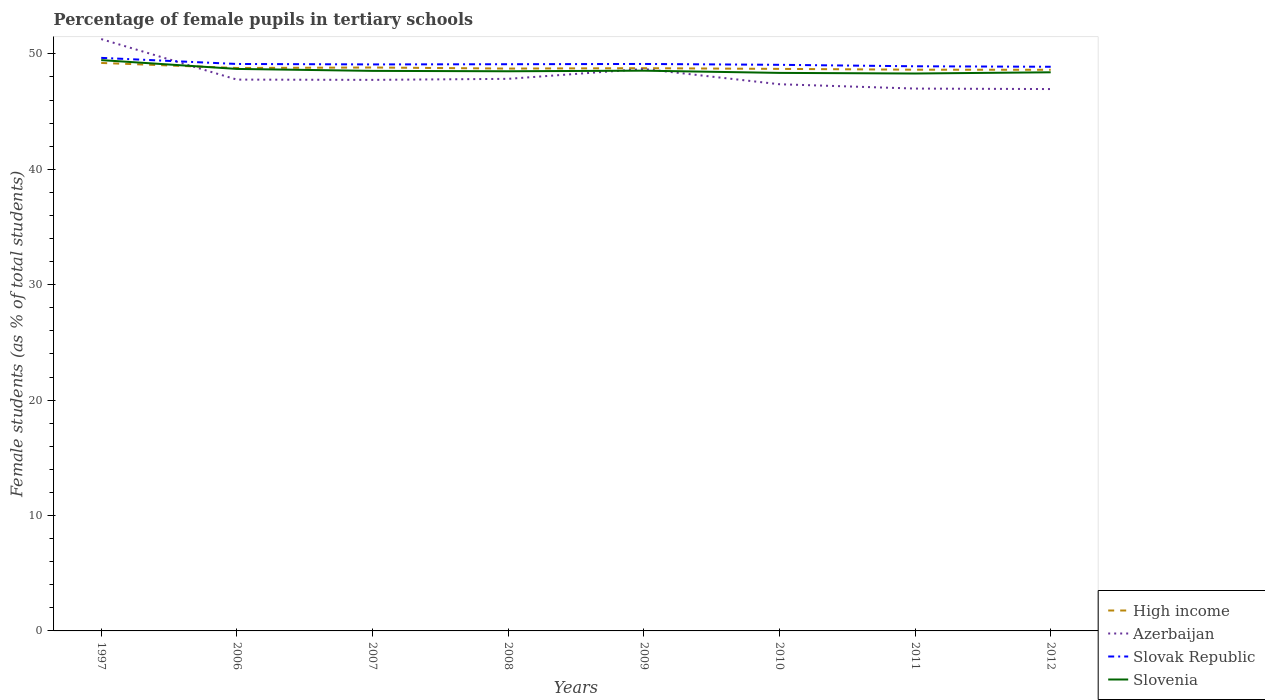Is the number of lines equal to the number of legend labels?
Your answer should be compact. Yes. Across all years, what is the maximum percentage of female pupils in tertiary schools in High income?
Offer a terse response. 48.62. What is the total percentage of female pupils in tertiary schools in Azerbaijan in the graph?
Offer a very short reply. 1.74. What is the difference between the highest and the second highest percentage of female pupils in tertiary schools in Slovak Republic?
Keep it short and to the point. 0.77. Is the percentage of female pupils in tertiary schools in Slovenia strictly greater than the percentage of female pupils in tertiary schools in Slovak Republic over the years?
Keep it short and to the point. Yes. How many lines are there?
Your answer should be very brief. 4. How many years are there in the graph?
Your answer should be very brief. 8. Are the values on the major ticks of Y-axis written in scientific E-notation?
Keep it short and to the point. No. Does the graph contain any zero values?
Your response must be concise. No. How many legend labels are there?
Offer a very short reply. 4. How are the legend labels stacked?
Make the answer very short. Vertical. What is the title of the graph?
Your answer should be compact. Percentage of female pupils in tertiary schools. What is the label or title of the X-axis?
Make the answer very short. Years. What is the label or title of the Y-axis?
Provide a short and direct response. Female students (as % of total students). What is the Female students (as % of total students) in High income in 1997?
Provide a short and direct response. 49.21. What is the Female students (as % of total students) in Azerbaijan in 1997?
Your response must be concise. 51.28. What is the Female students (as % of total students) of Slovak Republic in 1997?
Provide a short and direct response. 49.65. What is the Female students (as % of total students) in Slovenia in 1997?
Make the answer very short. 49.46. What is the Female students (as % of total students) of High income in 2006?
Keep it short and to the point. 48.78. What is the Female students (as % of total students) of Azerbaijan in 2006?
Give a very brief answer. 47.77. What is the Female students (as % of total students) of Slovak Republic in 2006?
Ensure brevity in your answer.  49.12. What is the Female students (as % of total students) of Slovenia in 2006?
Provide a short and direct response. 48.69. What is the Female students (as % of total students) of High income in 2007?
Ensure brevity in your answer.  48.82. What is the Female students (as % of total students) of Azerbaijan in 2007?
Offer a terse response. 47.74. What is the Female students (as % of total students) in Slovak Republic in 2007?
Provide a short and direct response. 49.08. What is the Female students (as % of total students) in Slovenia in 2007?
Your response must be concise. 48.52. What is the Female students (as % of total students) of High income in 2008?
Your answer should be very brief. 48.72. What is the Female students (as % of total students) in Azerbaijan in 2008?
Your answer should be compact. 47.83. What is the Female students (as % of total students) in Slovak Republic in 2008?
Keep it short and to the point. 49.1. What is the Female students (as % of total students) in Slovenia in 2008?
Make the answer very short. 48.49. What is the Female students (as % of total students) of High income in 2009?
Give a very brief answer. 48.76. What is the Female students (as % of total students) in Azerbaijan in 2009?
Your answer should be compact. 48.69. What is the Female students (as % of total students) of Slovak Republic in 2009?
Keep it short and to the point. 49.12. What is the Female students (as % of total students) of Slovenia in 2009?
Your response must be concise. 48.54. What is the Female students (as % of total students) in High income in 2010?
Your response must be concise. 48.7. What is the Female students (as % of total students) of Azerbaijan in 2010?
Your answer should be very brief. 47.37. What is the Female students (as % of total students) of Slovak Republic in 2010?
Provide a succinct answer. 49.05. What is the Female students (as % of total students) of Slovenia in 2010?
Your response must be concise. 48.35. What is the Female students (as % of total students) in High income in 2011?
Your response must be concise. 48.63. What is the Female students (as % of total students) in Azerbaijan in 2011?
Offer a terse response. 46.99. What is the Female students (as % of total students) of Slovak Republic in 2011?
Your answer should be compact. 48.92. What is the Female students (as % of total students) in Slovenia in 2011?
Provide a succinct answer. 48.3. What is the Female students (as % of total students) in High income in 2012?
Offer a terse response. 48.62. What is the Female students (as % of total students) in Azerbaijan in 2012?
Provide a short and direct response. 46.95. What is the Female students (as % of total students) of Slovak Republic in 2012?
Ensure brevity in your answer.  48.88. What is the Female students (as % of total students) of Slovenia in 2012?
Your answer should be compact. 48.4. Across all years, what is the maximum Female students (as % of total students) of High income?
Keep it short and to the point. 49.21. Across all years, what is the maximum Female students (as % of total students) of Azerbaijan?
Provide a short and direct response. 51.28. Across all years, what is the maximum Female students (as % of total students) in Slovak Republic?
Give a very brief answer. 49.65. Across all years, what is the maximum Female students (as % of total students) in Slovenia?
Ensure brevity in your answer.  49.46. Across all years, what is the minimum Female students (as % of total students) of High income?
Ensure brevity in your answer.  48.62. Across all years, what is the minimum Female students (as % of total students) of Azerbaijan?
Offer a very short reply. 46.95. Across all years, what is the minimum Female students (as % of total students) in Slovak Republic?
Keep it short and to the point. 48.88. Across all years, what is the minimum Female students (as % of total students) in Slovenia?
Keep it short and to the point. 48.3. What is the total Female students (as % of total students) in High income in the graph?
Your response must be concise. 390.23. What is the total Female students (as % of total students) in Azerbaijan in the graph?
Offer a terse response. 384.63. What is the total Female students (as % of total students) in Slovak Republic in the graph?
Your answer should be compact. 392.94. What is the total Female students (as % of total students) in Slovenia in the graph?
Ensure brevity in your answer.  388.76. What is the difference between the Female students (as % of total students) of High income in 1997 and that in 2006?
Offer a very short reply. 0.44. What is the difference between the Female students (as % of total students) of Azerbaijan in 1997 and that in 2006?
Your answer should be compact. 3.51. What is the difference between the Female students (as % of total students) of Slovak Republic in 1997 and that in 2006?
Your response must be concise. 0.53. What is the difference between the Female students (as % of total students) of Slovenia in 1997 and that in 2006?
Give a very brief answer. 0.76. What is the difference between the Female students (as % of total students) of High income in 1997 and that in 2007?
Your response must be concise. 0.4. What is the difference between the Female students (as % of total students) in Azerbaijan in 1997 and that in 2007?
Make the answer very short. 3.54. What is the difference between the Female students (as % of total students) in Slovak Republic in 1997 and that in 2007?
Keep it short and to the point. 0.57. What is the difference between the Female students (as % of total students) of Slovenia in 1997 and that in 2007?
Give a very brief answer. 0.93. What is the difference between the Female students (as % of total students) in High income in 1997 and that in 2008?
Your response must be concise. 0.49. What is the difference between the Female students (as % of total students) of Azerbaijan in 1997 and that in 2008?
Your answer should be compact. 3.45. What is the difference between the Female students (as % of total students) in Slovak Republic in 1997 and that in 2008?
Make the answer very short. 0.55. What is the difference between the Female students (as % of total students) of Slovenia in 1997 and that in 2008?
Your answer should be very brief. 0.97. What is the difference between the Female students (as % of total students) in High income in 1997 and that in 2009?
Make the answer very short. 0.45. What is the difference between the Female students (as % of total students) of Azerbaijan in 1997 and that in 2009?
Your answer should be compact. 2.59. What is the difference between the Female students (as % of total students) of Slovak Republic in 1997 and that in 2009?
Your answer should be very brief. 0.53. What is the difference between the Female students (as % of total students) in Slovenia in 1997 and that in 2009?
Keep it short and to the point. 0.92. What is the difference between the Female students (as % of total students) in High income in 1997 and that in 2010?
Keep it short and to the point. 0.51. What is the difference between the Female students (as % of total students) of Azerbaijan in 1997 and that in 2010?
Your response must be concise. 3.91. What is the difference between the Female students (as % of total students) in Slovak Republic in 1997 and that in 2010?
Keep it short and to the point. 0.6. What is the difference between the Female students (as % of total students) in Slovenia in 1997 and that in 2010?
Your response must be concise. 1.11. What is the difference between the Female students (as % of total students) of High income in 1997 and that in 2011?
Make the answer very short. 0.59. What is the difference between the Female students (as % of total students) of Azerbaijan in 1997 and that in 2011?
Give a very brief answer. 4.29. What is the difference between the Female students (as % of total students) of Slovak Republic in 1997 and that in 2011?
Provide a succinct answer. 0.73. What is the difference between the Female students (as % of total students) of Slovenia in 1997 and that in 2011?
Provide a short and direct response. 1.16. What is the difference between the Female students (as % of total students) of High income in 1997 and that in 2012?
Offer a very short reply. 0.59. What is the difference between the Female students (as % of total students) in Azerbaijan in 1997 and that in 2012?
Your answer should be very brief. 4.33. What is the difference between the Female students (as % of total students) of Slovak Republic in 1997 and that in 2012?
Ensure brevity in your answer.  0.77. What is the difference between the Female students (as % of total students) of Slovenia in 1997 and that in 2012?
Your answer should be very brief. 1.06. What is the difference between the Female students (as % of total students) in High income in 2006 and that in 2007?
Provide a succinct answer. -0.04. What is the difference between the Female students (as % of total students) in Azerbaijan in 2006 and that in 2007?
Make the answer very short. 0.02. What is the difference between the Female students (as % of total students) in Slovak Republic in 2006 and that in 2007?
Ensure brevity in your answer.  0.04. What is the difference between the Female students (as % of total students) in Slovenia in 2006 and that in 2007?
Give a very brief answer. 0.17. What is the difference between the Female students (as % of total students) in High income in 2006 and that in 2008?
Keep it short and to the point. 0.05. What is the difference between the Female students (as % of total students) of Azerbaijan in 2006 and that in 2008?
Provide a succinct answer. -0.07. What is the difference between the Female students (as % of total students) of Slovak Republic in 2006 and that in 2008?
Make the answer very short. 0.02. What is the difference between the Female students (as % of total students) of Slovenia in 2006 and that in 2008?
Your answer should be very brief. 0.2. What is the difference between the Female students (as % of total students) in High income in 2006 and that in 2009?
Keep it short and to the point. 0.02. What is the difference between the Female students (as % of total students) of Azerbaijan in 2006 and that in 2009?
Provide a succinct answer. -0.92. What is the difference between the Female students (as % of total students) in Slovak Republic in 2006 and that in 2009?
Provide a succinct answer. -0. What is the difference between the Female students (as % of total students) in Slovenia in 2006 and that in 2009?
Your answer should be compact. 0.15. What is the difference between the Female students (as % of total students) in High income in 2006 and that in 2010?
Make the answer very short. 0.08. What is the difference between the Female students (as % of total students) in Azerbaijan in 2006 and that in 2010?
Provide a succinct answer. 0.4. What is the difference between the Female students (as % of total students) in Slovak Republic in 2006 and that in 2010?
Make the answer very short. 0.07. What is the difference between the Female students (as % of total students) of Slovenia in 2006 and that in 2010?
Make the answer very short. 0.34. What is the difference between the Female students (as % of total students) in High income in 2006 and that in 2011?
Provide a succinct answer. 0.15. What is the difference between the Female students (as % of total students) in Azerbaijan in 2006 and that in 2011?
Your answer should be very brief. 0.78. What is the difference between the Female students (as % of total students) in Slovak Republic in 2006 and that in 2011?
Provide a short and direct response. 0.2. What is the difference between the Female students (as % of total students) of Slovenia in 2006 and that in 2011?
Provide a short and direct response. 0.4. What is the difference between the Female students (as % of total students) in High income in 2006 and that in 2012?
Give a very brief answer. 0.16. What is the difference between the Female students (as % of total students) in Azerbaijan in 2006 and that in 2012?
Offer a terse response. 0.82. What is the difference between the Female students (as % of total students) in Slovak Republic in 2006 and that in 2012?
Your answer should be very brief. 0.24. What is the difference between the Female students (as % of total students) in Slovenia in 2006 and that in 2012?
Provide a succinct answer. 0.29. What is the difference between the Female students (as % of total students) of High income in 2007 and that in 2008?
Make the answer very short. 0.09. What is the difference between the Female students (as % of total students) of Azerbaijan in 2007 and that in 2008?
Ensure brevity in your answer.  -0.09. What is the difference between the Female students (as % of total students) of Slovak Republic in 2007 and that in 2008?
Offer a terse response. -0.02. What is the difference between the Female students (as % of total students) of High income in 2007 and that in 2009?
Make the answer very short. 0.06. What is the difference between the Female students (as % of total students) in Azerbaijan in 2007 and that in 2009?
Provide a succinct answer. -0.94. What is the difference between the Female students (as % of total students) of Slovak Republic in 2007 and that in 2009?
Give a very brief answer. -0.04. What is the difference between the Female students (as % of total students) of Slovenia in 2007 and that in 2009?
Your answer should be very brief. -0.02. What is the difference between the Female students (as % of total students) of High income in 2007 and that in 2010?
Provide a short and direct response. 0.12. What is the difference between the Female students (as % of total students) of Azerbaijan in 2007 and that in 2010?
Make the answer very short. 0.38. What is the difference between the Female students (as % of total students) in Slovak Republic in 2007 and that in 2010?
Your answer should be compact. 0.03. What is the difference between the Female students (as % of total students) of Slovenia in 2007 and that in 2010?
Offer a very short reply. 0.17. What is the difference between the Female students (as % of total students) in High income in 2007 and that in 2011?
Make the answer very short. 0.19. What is the difference between the Female students (as % of total students) in Azerbaijan in 2007 and that in 2011?
Your response must be concise. 0.75. What is the difference between the Female students (as % of total students) of Slovak Republic in 2007 and that in 2011?
Keep it short and to the point. 0.16. What is the difference between the Female students (as % of total students) of Slovenia in 2007 and that in 2011?
Your response must be concise. 0.23. What is the difference between the Female students (as % of total students) in High income in 2007 and that in 2012?
Ensure brevity in your answer.  0.2. What is the difference between the Female students (as % of total students) of Azerbaijan in 2007 and that in 2012?
Offer a terse response. 0.8. What is the difference between the Female students (as % of total students) of Slovak Republic in 2007 and that in 2012?
Provide a succinct answer. 0.2. What is the difference between the Female students (as % of total students) of Slovenia in 2007 and that in 2012?
Your answer should be compact. 0.12. What is the difference between the Female students (as % of total students) in High income in 2008 and that in 2009?
Your answer should be very brief. -0.03. What is the difference between the Female students (as % of total students) of Azerbaijan in 2008 and that in 2009?
Make the answer very short. -0.86. What is the difference between the Female students (as % of total students) of Slovak Republic in 2008 and that in 2009?
Keep it short and to the point. -0.02. What is the difference between the Female students (as % of total students) in Slovenia in 2008 and that in 2009?
Offer a very short reply. -0.05. What is the difference between the Female students (as % of total students) in High income in 2008 and that in 2010?
Keep it short and to the point. 0.03. What is the difference between the Female students (as % of total students) in Azerbaijan in 2008 and that in 2010?
Offer a very short reply. 0.47. What is the difference between the Female students (as % of total students) of Slovak Republic in 2008 and that in 2010?
Offer a very short reply. 0.05. What is the difference between the Female students (as % of total students) in Slovenia in 2008 and that in 2010?
Provide a short and direct response. 0.14. What is the difference between the Female students (as % of total students) of High income in 2008 and that in 2011?
Make the answer very short. 0.1. What is the difference between the Female students (as % of total students) of Azerbaijan in 2008 and that in 2011?
Your response must be concise. 0.84. What is the difference between the Female students (as % of total students) of Slovak Republic in 2008 and that in 2011?
Offer a very short reply. 0.18. What is the difference between the Female students (as % of total students) of Slovenia in 2008 and that in 2011?
Your answer should be very brief. 0.19. What is the difference between the Female students (as % of total students) of High income in 2008 and that in 2012?
Your response must be concise. 0.11. What is the difference between the Female students (as % of total students) in Azerbaijan in 2008 and that in 2012?
Your response must be concise. 0.88. What is the difference between the Female students (as % of total students) in Slovak Republic in 2008 and that in 2012?
Your answer should be very brief. 0.22. What is the difference between the Female students (as % of total students) of Slovenia in 2008 and that in 2012?
Make the answer very short. 0.09. What is the difference between the Female students (as % of total students) of High income in 2009 and that in 2010?
Offer a very short reply. 0.06. What is the difference between the Female students (as % of total students) of Azerbaijan in 2009 and that in 2010?
Provide a succinct answer. 1.32. What is the difference between the Female students (as % of total students) in Slovak Republic in 2009 and that in 2010?
Ensure brevity in your answer.  0.07. What is the difference between the Female students (as % of total students) in Slovenia in 2009 and that in 2010?
Offer a very short reply. 0.19. What is the difference between the Female students (as % of total students) of High income in 2009 and that in 2011?
Your answer should be compact. 0.13. What is the difference between the Female students (as % of total students) of Azerbaijan in 2009 and that in 2011?
Offer a very short reply. 1.7. What is the difference between the Female students (as % of total students) of Slovak Republic in 2009 and that in 2011?
Provide a succinct answer. 0.2. What is the difference between the Female students (as % of total students) of Slovenia in 2009 and that in 2011?
Offer a terse response. 0.24. What is the difference between the Female students (as % of total students) of High income in 2009 and that in 2012?
Make the answer very short. 0.14. What is the difference between the Female students (as % of total students) in Azerbaijan in 2009 and that in 2012?
Offer a very short reply. 1.74. What is the difference between the Female students (as % of total students) in Slovak Republic in 2009 and that in 2012?
Your response must be concise. 0.24. What is the difference between the Female students (as % of total students) of Slovenia in 2009 and that in 2012?
Offer a terse response. 0.14. What is the difference between the Female students (as % of total students) in High income in 2010 and that in 2011?
Keep it short and to the point. 0.07. What is the difference between the Female students (as % of total students) in Azerbaijan in 2010 and that in 2011?
Your answer should be compact. 0.38. What is the difference between the Female students (as % of total students) in Slovak Republic in 2010 and that in 2011?
Keep it short and to the point. 0.13. What is the difference between the Female students (as % of total students) in Slovenia in 2010 and that in 2011?
Make the answer very short. 0.05. What is the difference between the Female students (as % of total students) of High income in 2010 and that in 2012?
Your answer should be compact. 0.08. What is the difference between the Female students (as % of total students) of Azerbaijan in 2010 and that in 2012?
Provide a short and direct response. 0.42. What is the difference between the Female students (as % of total students) of Slovak Republic in 2010 and that in 2012?
Provide a short and direct response. 0.17. What is the difference between the Female students (as % of total students) in Slovenia in 2010 and that in 2012?
Your answer should be compact. -0.05. What is the difference between the Female students (as % of total students) in High income in 2011 and that in 2012?
Your answer should be very brief. 0.01. What is the difference between the Female students (as % of total students) in Azerbaijan in 2011 and that in 2012?
Ensure brevity in your answer.  0.04. What is the difference between the Female students (as % of total students) of Slovak Republic in 2011 and that in 2012?
Give a very brief answer. 0.04. What is the difference between the Female students (as % of total students) of Slovenia in 2011 and that in 2012?
Provide a succinct answer. -0.1. What is the difference between the Female students (as % of total students) in High income in 1997 and the Female students (as % of total students) in Azerbaijan in 2006?
Ensure brevity in your answer.  1.44. What is the difference between the Female students (as % of total students) in High income in 1997 and the Female students (as % of total students) in Slovak Republic in 2006?
Offer a very short reply. 0.09. What is the difference between the Female students (as % of total students) in High income in 1997 and the Female students (as % of total students) in Slovenia in 2006?
Offer a terse response. 0.52. What is the difference between the Female students (as % of total students) of Azerbaijan in 1997 and the Female students (as % of total students) of Slovak Republic in 2006?
Make the answer very short. 2.16. What is the difference between the Female students (as % of total students) of Azerbaijan in 1997 and the Female students (as % of total students) of Slovenia in 2006?
Your response must be concise. 2.59. What is the difference between the Female students (as % of total students) of Slovak Republic in 1997 and the Female students (as % of total students) of Slovenia in 2006?
Give a very brief answer. 0.96. What is the difference between the Female students (as % of total students) of High income in 1997 and the Female students (as % of total students) of Azerbaijan in 2007?
Keep it short and to the point. 1.47. What is the difference between the Female students (as % of total students) of High income in 1997 and the Female students (as % of total students) of Slovak Republic in 2007?
Your response must be concise. 0.13. What is the difference between the Female students (as % of total students) of High income in 1997 and the Female students (as % of total students) of Slovenia in 2007?
Keep it short and to the point. 0.69. What is the difference between the Female students (as % of total students) in Azerbaijan in 1997 and the Female students (as % of total students) in Slovak Republic in 2007?
Offer a terse response. 2.2. What is the difference between the Female students (as % of total students) of Azerbaijan in 1997 and the Female students (as % of total students) of Slovenia in 2007?
Make the answer very short. 2.76. What is the difference between the Female students (as % of total students) of Slovak Republic in 1997 and the Female students (as % of total students) of Slovenia in 2007?
Provide a succinct answer. 1.13. What is the difference between the Female students (as % of total students) in High income in 1997 and the Female students (as % of total students) in Azerbaijan in 2008?
Keep it short and to the point. 1.38. What is the difference between the Female students (as % of total students) of High income in 1997 and the Female students (as % of total students) of Slovak Republic in 2008?
Keep it short and to the point. 0.11. What is the difference between the Female students (as % of total students) in High income in 1997 and the Female students (as % of total students) in Slovenia in 2008?
Your answer should be compact. 0.72. What is the difference between the Female students (as % of total students) in Azerbaijan in 1997 and the Female students (as % of total students) in Slovak Republic in 2008?
Offer a terse response. 2.18. What is the difference between the Female students (as % of total students) in Azerbaijan in 1997 and the Female students (as % of total students) in Slovenia in 2008?
Keep it short and to the point. 2.79. What is the difference between the Female students (as % of total students) of Slovak Republic in 1997 and the Female students (as % of total students) of Slovenia in 2008?
Provide a succinct answer. 1.16. What is the difference between the Female students (as % of total students) of High income in 1997 and the Female students (as % of total students) of Azerbaijan in 2009?
Your answer should be compact. 0.52. What is the difference between the Female students (as % of total students) of High income in 1997 and the Female students (as % of total students) of Slovak Republic in 2009?
Your response must be concise. 0.09. What is the difference between the Female students (as % of total students) of High income in 1997 and the Female students (as % of total students) of Slovenia in 2009?
Your response must be concise. 0.67. What is the difference between the Female students (as % of total students) of Azerbaijan in 1997 and the Female students (as % of total students) of Slovak Republic in 2009?
Provide a succinct answer. 2.16. What is the difference between the Female students (as % of total students) of Azerbaijan in 1997 and the Female students (as % of total students) of Slovenia in 2009?
Make the answer very short. 2.74. What is the difference between the Female students (as % of total students) of Slovak Republic in 1997 and the Female students (as % of total students) of Slovenia in 2009?
Keep it short and to the point. 1.11. What is the difference between the Female students (as % of total students) in High income in 1997 and the Female students (as % of total students) in Azerbaijan in 2010?
Provide a succinct answer. 1.84. What is the difference between the Female students (as % of total students) of High income in 1997 and the Female students (as % of total students) of Slovak Republic in 2010?
Ensure brevity in your answer.  0.16. What is the difference between the Female students (as % of total students) of High income in 1997 and the Female students (as % of total students) of Slovenia in 2010?
Give a very brief answer. 0.86. What is the difference between the Female students (as % of total students) in Azerbaijan in 1997 and the Female students (as % of total students) in Slovak Republic in 2010?
Your response must be concise. 2.23. What is the difference between the Female students (as % of total students) in Azerbaijan in 1997 and the Female students (as % of total students) in Slovenia in 2010?
Your response must be concise. 2.93. What is the difference between the Female students (as % of total students) in Slovak Republic in 1997 and the Female students (as % of total students) in Slovenia in 2010?
Keep it short and to the point. 1.3. What is the difference between the Female students (as % of total students) in High income in 1997 and the Female students (as % of total students) in Azerbaijan in 2011?
Offer a terse response. 2.22. What is the difference between the Female students (as % of total students) in High income in 1997 and the Female students (as % of total students) in Slovak Republic in 2011?
Provide a succinct answer. 0.29. What is the difference between the Female students (as % of total students) of High income in 1997 and the Female students (as % of total students) of Slovenia in 2011?
Provide a short and direct response. 0.91. What is the difference between the Female students (as % of total students) of Azerbaijan in 1997 and the Female students (as % of total students) of Slovak Republic in 2011?
Your answer should be compact. 2.36. What is the difference between the Female students (as % of total students) of Azerbaijan in 1997 and the Female students (as % of total students) of Slovenia in 2011?
Ensure brevity in your answer.  2.98. What is the difference between the Female students (as % of total students) in Slovak Republic in 1997 and the Female students (as % of total students) in Slovenia in 2011?
Your answer should be compact. 1.35. What is the difference between the Female students (as % of total students) of High income in 1997 and the Female students (as % of total students) of Azerbaijan in 2012?
Ensure brevity in your answer.  2.26. What is the difference between the Female students (as % of total students) of High income in 1997 and the Female students (as % of total students) of Slovak Republic in 2012?
Make the answer very short. 0.33. What is the difference between the Female students (as % of total students) of High income in 1997 and the Female students (as % of total students) of Slovenia in 2012?
Keep it short and to the point. 0.81. What is the difference between the Female students (as % of total students) in Azerbaijan in 1997 and the Female students (as % of total students) in Slovak Republic in 2012?
Ensure brevity in your answer.  2.4. What is the difference between the Female students (as % of total students) in Azerbaijan in 1997 and the Female students (as % of total students) in Slovenia in 2012?
Ensure brevity in your answer.  2.88. What is the difference between the Female students (as % of total students) in Slovak Republic in 1997 and the Female students (as % of total students) in Slovenia in 2012?
Give a very brief answer. 1.25. What is the difference between the Female students (as % of total students) in High income in 2006 and the Female students (as % of total students) in Azerbaijan in 2007?
Offer a terse response. 1.03. What is the difference between the Female students (as % of total students) of High income in 2006 and the Female students (as % of total students) of Slovak Republic in 2007?
Offer a terse response. -0.31. What is the difference between the Female students (as % of total students) in High income in 2006 and the Female students (as % of total students) in Slovenia in 2007?
Offer a terse response. 0.25. What is the difference between the Female students (as % of total students) in Azerbaijan in 2006 and the Female students (as % of total students) in Slovak Republic in 2007?
Offer a terse response. -1.32. What is the difference between the Female students (as % of total students) of Azerbaijan in 2006 and the Female students (as % of total students) of Slovenia in 2007?
Provide a succinct answer. -0.76. What is the difference between the Female students (as % of total students) of Slovak Republic in 2006 and the Female students (as % of total students) of Slovenia in 2007?
Make the answer very short. 0.6. What is the difference between the Female students (as % of total students) of High income in 2006 and the Female students (as % of total students) of Azerbaijan in 2008?
Keep it short and to the point. 0.94. What is the difference between the Female students (as % of total students) of High income in 2006 and the Female students (as % of total students) of Slovak Republic in 2008?
Give a very brief answer. -0.33. What is the difference between the Female students (as % of total students) in High income in 2006 and the Female students (as % of total students) in Slovenia in 2008?
Make the answer very short. 0.28. What is the difference between the Female students (as % of total students) in Azerbaijan in 2006 and the Female students (as % of total students) in Slovak Republic in 2008?
Your response must be concise. -1.33. What is the difference between the Female students (as % of total students) in Azerbaijan in 2006 and the Female students (as % of total students) in Slovenia in 2008?
Offer a very short reply. -0.72. What is the difference between the Female students (as % of total students) of Slovak Republic in 2006 and the Female students (as % of total students) of Slovenia in 2008?
Your answer should be compact. 0.63. What is the difference between the Female students (as % of total students) of High income in 2006 and the Female students (as % of total students) of Azerbaijan in 2009?
Ensure brevity in your answer.  0.09. What is the difference between the Female students (as % of total students) of High income in 2006 and the Female students (as % of total students) of Slovak Republic in 2009?
Provide a short and direct response. -0.35. What is the difference between the Female students (as % of total students) of High income in 2006 and the Female students (as % of total students) of Slovenia in 2009?
Offer a very short reply. 0.23. What is the difference between the Female students (as % of total students) of Azerbaijan in 2006 and the Female students (as % of total students) of Slovak Republic in 2009?
Give a very brief answer. -1.35. What is the difference between the Female students (as % of total students) of Azerbaijan in 2006 and the Female students (as % of total students) of Slovenia in 2009?
Ensure brevity in your answer.  -0.77. What is the difference between the Female students (as % of total students) in Slovak Republic in 2006 and the Female students (as % of total students) in Slovenia in 2009?
Your answer should be compact. 0.58. What is the difference between the Female students (as % of total students) in High income in 2006 and the Female students (as % of total students) in Azerbaijan in 2010?
Provide a short and direct response. 1.41. What is the difference between the Female students (as % of total students) in High income in 2006 and the Female students (as % of total students) in Slovak Republic in 2010?
Provide a succinct answer. -0.27. What is the difference between the Female students (as % of total students) in High income in 2006 and the Female students (as % of total students) in Slovenia in 2010?
Ensure brevity in your answer.  0.43. What is the difference between the Female students (as % of total students) of Azerbaijan in 2006 and the Female students (as % of total students) of Slovak Republic in 2010?
Provide a succinct answer. -1.28. What is the difference between the Female students (as % of total students) of Azerbaijan in 2006 and the Female students (as % of total students) of Slovenia in 2010?
Provide a short and direct response. -0.58. What is the difference between the Female students (as % of total students) in Slovak Republic in 2006 and the Female students (as % of total students) in Slovenia in 2010?
Offer a very short reply. 0.77. What is the difference between the Female students (as % of total students) in High income in 2006 and the Female students (as % of total students) in Azerbaijan in 2011?
Provide a short and direct response. 1.78. What is the difference between the Female students (as % of total students) in High income in 2006 and the Female students (as % of total students) in Slovak Republic in 2011?
Keep it short and to the point. -0.15. What is the difference between the Female students (as % of total students) of High income in 2006 and the Female students (as % of total students) of Slovenia in 2011?
Make the answer very short. 0.48. What is the difference between the Female students (as % of total students) of Azerbaijan in 2006 and the Female students (as % of total students) of Slovak Republic in 2011?
Provide a short and direct response. -1.15. What is the difference between the Female students (as % of total students) of Azerbaijan in 2006 and the Female students (as % of total students) of Slovenia in 2011?
Offer a terse response. -0.53. What is the difference between the Female students (as % of total students) of Slovak Republic in 2006 and the Female students (as % of total students) of Slovenia in 2011?
Provide a short and direct response. 0.83. What is the difference between the Female students (as % of total students) in High income in 2006 and the Female students (as % of total students) in Azerbaijan in 2012?
Your answer should be very brief. 1.83. What is the difference between the Female students (as % of total students) in High income in 2006 and the Female students (as % of total students) in Slovak Republic in 2012?
Offer a terse response. -0.11. What is the difference between the Female students (as % of total students) of High income in 2006 and the Female students (as % of total students) of Slovenia in 2012?
Make the answer very short. 0.37. What is the difference between the Female students (as % of total students) in Azerbaijan in 2006 and the Female students (as % of total students) in Slovak Republic in 2012?
Keep it short and to the point. -1.11. What is the difference between the Female students (as % of total students) of Azerbaijan in 2006 and the Female students (as % of total students) of Slovenia in 2012?
Ensure brevity in your answer.  -0.63. What is the difference between the Female students (as % of total students) in Slovak Republic in 2006 and the Female students (as % of total students) in Slovenia in 2012?
Your answer should be compact. 0.72. What is the difference between the Female students (as % of total students) in High income in 2007 and the Female students (as % of total students) in Azerbaijan in 2008?
Offer a terse response. 0.98. What is the difference between the Female students (as % of total students) of High income in 2007 and the Female students (as % of total students) of Slovak Republic in 2008?
Give a very brief answer. -0.28. What is the difference between the Female students (as % of total students) in High income in 2007 and the Female students (as % of total students) in Slovenia in 2008?
Give a very brief answer. 0.32. What is the difference between the Female students (as % of total students) of Azerbaijan in 2007 and the Female students (as % of total students) of Slovak Republic in 2008?
Give a very brief answer. -1.36. What is the difference between the Female students (as % of total students) of Azerbaijan in 2007 and the Female students (as % of total students) of Slovenia in 2008?
Give a very brief answer. -0.75. What is the difference between the Female students (as % of total students) of Slovak Republic in 2007 and the Female students (as % of total students) of Slovenia in 2008?
Offer a very short reply. 0.59. What is the difference between the Female students (as % of total students) of High income in 2007 and the Female students (as % of total students) of Azerbaijan in 2009?
Provide a succinct answer. 0.13. What is the difference between the Female students (as % of total students) of High income in 2007 and the Female students (as % of total students) of Slovak Republic in 2009?
Offer a very short reply. -0.31. What is the difference between the Female students (as % of total students) of High income in 2007 and the Female students (as % of total students) of Slovenia in 2009?
Your answer should be compact. 0.27. What is the difference between the Female students (as % of total students) of Azerbaijan in 2007 and the Female students (as % of total students) of Slovak Republic in 2009?
Your response must be concise. -1.38. What is the difference between the Female students (as % of total students) of Azerbaijan in 2007 and the Female students (as % of total students) of Slovenia in 2009?
Ensure brevity in your answer.  -0.8. What is the difference between the Female students (as % of total students) of Slovak Republic in 2007 and the Female students (as % of total students) of Slovenia in 2009?
Make the answer very short. 0.54. What is the difference between the Female students (as % of total students) of High income in 2007 and the Female students (as % of total students) of Azerbaijan in 2010?
Keep it short and to the point. 1.45. What is the difference between the Female students (as % of total students) of High income in 2007 and the Female students (as % of total students) of Slovak Republic in 2010?
Your answer should be very brief. -0.23. What is the difference between the Female students (as % of total students) in High income in 2007 and the Female students (as % of total students) in Slovenia in 2010?
Give a very brief answer. 0.47. What is the difference between the Female students (as % of total students) in Azerbaijan in 2007 and the Female students (as % of total students) in Slovak Republic in 2010?
Make the answer very short. -1.3. What is the difference between the Female students (as % of total students) of Azerbaijan in 2007 and the Female students (as % of total students) of Slovenia in 2010?
Your answer should be very brief. -0.6. What is the difference between the Female students (as % of total students) of Slovak Republic in 2007 and the Female students (as % of total students) of Slovenia in 2010?
Provide a succinct answer. 0.73. What is the difference between the Female students (as % of total students) of High income in 2007 and the Female students (as % of total students) of Azerbaijan in 2011?
Your answer should be compact. 1.83. What is the difference between the Female students (as % of total students) of High income in 2007 and the Female students (as % of total students) of Slovak Republic in 2011?
Your answer should be compact. -0.11. What is the difference between the Female students (as % of total students) in High income in 2007 and the Female students (as % of total students) in Slovenia in 2011?
Your answer should be very brief. 0.52. What is the difference between the Female students (as % of total students) in Azerbaijan in 2007 and the Female students (as % of total students) in Slovak Republic in 2011?
Offer a very short reply. -1.18. What is the difference between the Female students (as % of total students) of Azerbaijan in 2007 and the Female students (as % of total students) of Slovenia in 2011?
Make the answer very short. -0.55. What is the difference between the Female students (as % of total students) in Slovak Republic in 2007 and the Female students (as % of total students) in Slovenia in 2011?
Ensure brevity in your answer.  0.79. What is the difference between the Female students (as % of total students) of High income in 2007 and the Female students (as % of total students) of Azerbaijan in 2012?
Ensure brevity in your answer.  1.87. What is the difference between the Female students (as % of total students) in High income in 2007 and the Female students (as % of total students) in Slovak Republic in 2012?
Your response must be concise. -0.06. What is the difference between the Female students (as % of total students) of High income in 2007 and the Female students (as % of total students) of Slovenia in 2012?
Offer a terse response. 0.41. What is the difference between the Female students (as % of total students) in Azerbaijan in 2007 and the Female students (as % of total students) in Slovak Republic in 2012?
Make the answer very short. -1.14. What is the difference between the Female students (as % of total students) in Azerbaijan in 2007 and the Female students (as % of total students) in Slovenia in 2012?
Keep it short and to the point. -0.66. What is the difference between the Female students (as % of total students) of Slovak Republic in 2007 and the Female students (as % of total students) of Slovenia in 2012?
Ensure brevity in your answer.  0.68. What is the difference between the Female students (as % of total students) of High income in 2008 and the Female students (as % of total students) of Azerbaijan in 2009?
Make the answer very short. 0.04. What is the difference between the Female students (as % of total students) in High income in 2008 and the Female students (as % of total students) in Slovak Republic in 2009?
Offer a terse response. -0.4. What is the difference between the Female students (as % of total students) of High income in 2008 and the Female students (as % of total students) of Slovenia in 2009?
Ensure brevity in your answer.  0.18. What is the difference between the Female students (as % of total students) of Azerbaijan in 2008 and the Female students (as % of total students) of Slovak Republic in 2009?
Give a very brief answer. -1.29. What is the difference between the Female students (as % of total students) in Azerbaijan in 2008 and the Female students (as % of total students) in Slovenia in 2009?
Offer a terse response. -0.71. What is the difference between the Female students (as % of total students) of Slovak Republic in 2008 and the Female students (as % of total students) of Slovenia in 2009?
Provide a short and direct response. 0.56. What is the difference between the Female students (as % of total students) in High income in 2008 and the Female students (as % of total students) in Azerbaijan in 2010?
Keep it short and to the point. 1.36. What is the difference between the Female students (as % of total students) of High income in 2008 and the Female students (as % of total students) of Slovak Republic in 2010?
Your response must be concise. -0.32. What is the difference between the Female students (as % of total students) of High income in 2008 and the Female students (as % of total students) of Slovenia in 2010?
Keep it short and to the point. 0.38. What is the difference between the Female students (as % of total students) in Azerbaijan in 2008 and the Female students (as % of total students) in Slovak Republic in 2010?
Provide a succinct answer. -1.22. What is the difference between the Female students (as % of total students) of Azerbaijan in 2008 and the Female students (as % of total students) of Slovenia in 2010?
Ensure brevity in your answer.  -0.52. What is the difference between the Female students (as % of total students) in Slovak Republic in 2008 and the Female students (as % of total students) in Slovenia in 2010?
Ensure brevity in your answer.  0.75. What is the difference between the Female students (as % of total students) in High income in 2008 and the Female students (as % of total students) in Azerbaijan in 2011?
Your answer should be very brief. 1.73. What is the difference between the Female students (as % of total students) in High income in 2008 and the Female students (as % of total students) in Slovak Republic in 2011?
Your response must be concise. -0.2. What is the difference between the Female students (as % of total students) of High income in 2008 and the Female students (as % of total students) of Slovenia in 2011?
Keep it short and to the point. 0.43. What is the difference between the Female students (as % of total students) in Azerbaijan in 2008 and the Female students (as % of total students) in Slovak Republic in 2011?
Keep it short and to the point. -1.09. What is the difference between the Female students (as % of total students) in Azerbaijan in 2008 and the Female students (as % of total students) in Slovenia in 2011?
Your response must be concise. -0.46. What is the difference between the Female students (as % of total students) of Slovak Republic in 2008 and the Female students (as % of total students) of Slovenia in 2011?
Provide a succinct answer. 0.8. What is the difference between the Female students (as % of total students) in High income in 2008 and the Female students (as % of total students) in Azerbaijan in 2012?
Make the answer very short. 1.78. What is the difference between the Female students (as % of total students) of High income in 2008 and the Female students (as % of total students) of Slovak Republic in 2012?
Provide a short and direct response. -0.16. What is the difference between the Female students (as % of total students) of High income in 2008 and the Female students (as % of total students) of Slovenia in 2012?
Ensure brevity in your answer.  0.32. What is the difference between the Female students (as % of total students) in Azerbaijan in 2008 and the Female students (as % of total students) in Slovak Republic in 2012?
Make the answer very short. -1.05. What is the difference between the Female students (as % of total students) of Azerbaijan in 2008 and the Female students (as % of total students) of Slovenia in 2012?
Provide a short and direct response. -0.57. What is the difference between the Female students (as % of total students) in Slovak Republic in 2008 and the Female students (as % of total students) in Slovenia in 2012?
Offer a very short reply. 0.7. What is the difference between the Female students (as % of total students) in High income in 2009 and the Female students (as % of total students) in Azerbaijan in 2010?
Your answer should be compact. 1.39. What is the difference between the Female students (as % of total students) in High income in 2009 and the Female students (as % of total students) in Slovak Republic in 2010?
Ensure brevity in your answer.  -0.29. What is the difference between the Female students (as % of total students) of High income in 2009 and the Female students (as % of total students) of Slovenia in 2010?
Your response must be concise. 0.41. What is the difference between the Female students (as % of total students) in Azerbaijan in 2009 and the Female students (as % of total students) in Slovak Republic in 2010?
Your response must be concise. -0.36. What is the difference between the Female students (as % of total students) in Azerbaijan in 2009 and the Female students (as % of total students) in Slovenia in 2010?
Provide a short and direct response. 0.34. What is the difference between the Female students (as % of total students) in Slovak Republic in 2009 and the Female students (as % of total students) in Slovenia in 2010?
Give a very brief answer. 0.77. What is the difference between the Female students (as % of total students) of High income in 2009 and the Female students (as % of total students) of Azerbaijan in 2011?
Your answer should be compact. 1.77. What is the difference between the Female students (as % of total students) in High income in 2009 and the Female students (as % of total students) in Slovak Republic in 2011?
Your answer should be compact. -0.17. What is the difference between the Female students (as % of total students) of High income in 2009 and the Female students (as % of total students) of Slovenia in 2011?
Your answer should be compact. 0.46. What is the difference between the Female students (as % of total students) in Azerbaijan in 2009 and the Female students (as % of total students) in Slovak Republic in 2011?
Provide a short and direct response. -0.23. What is the difference between the Female students (as % of total students) in Azerbaijan in 2009 and the Female students (as % of total students) in Slovenia in 2011?
Provide a succinct answer. 0.39. What is the difference between the Female students (as % of total students) in Slovak Republic in 2009 and the Female students (as % of total students) in Slovenia in 2011?
Offer a terse response. 0.83. What is the difference between the Female students (as % of total students) in High income in 2009 and the Female students (as % of total students) in Azerbaijan in 2012?
Ensure brevity in your answer.  1.81. What is the difference between the Female students (as % of total students) in High income in 2009 and the Female students (as % of total students) in Slovak Republic in 2012?
Keep it short and to the point. -0.12. What is the difference between the Female students (as % of total students) of High income in 2009 and the Female students (as % of total students) of Slovenia in 2012?
Ensure brevity in your answer.  0.36. What is the difference between the Female students (as % of total students) of Azerbaijan in 2009 and the Female students (as % of total students) of Slovak Republic in 2012?
Ensure brevity in your answer.  -0.19. What is the difference between the Female students (as % of total students) in Azerbaijan in 2009 and the Female students (as % of total students) in Slovenia in 2012?
Offer a terse response. 0.29. What is the difference between the Female students (as % of total students) in Slovak Republic in 2009 and the Female students (as % of total students) in Slovenia in 2012?
Provide a succinct answer. 0.72. What is the difference between the Female students (as % of total students) in High income in 2010 and the Female students (as % of total students) in Azerbaijan in 2011?
Make the answer very short. 1.71. What is the difference between the Female students (as % of total students) of High income in 2010 and the Female students (as % of total students) of Slovak Republic in 2011?
Your answer should be compact. -0.23. What is the difference between the Female students (as % of total students) of High income in 2010 and the Female students (as % of total students) of Slovenia in 2011?
Your answer should be compact. 0.4. What is the difference between the Female students (as % of total students) in Azerbaijan in 2010 and the Female students (as % of total students) in Slovak Republic in 2011?
Give a very brief answer. -1.56. What is the difference between the Female students (as % of total students) in Azerbaijan in 2010 and the Female students (as % of total students) in Slovenia in 2011?
Your answer should be very brief. -0.93. What is the difference between the Female students (as % of total students) in Slovak Republic in 2010 and the Female students (as % of total students) in Slovenia in 2011?
Your answer should be very brief. 0.75. What is the difference between the Female students (as % of total students) in High income in 2010 and the Female students (as % of total students) in Azerbaijan in 2012?
Provide a succinct answer. 1.75. What is the difference between the Female students (as % of total students) in High income in 2010 and the Female students (as % of total students) in Slovak Republic in 2012?
Your answer should be compact. -0.18. What is the difference between the Female students (as % of total students) in High income in 2010 and the Female students (as % of total students) in Slovenia in 2012?
Offer a terse response. 0.3. What is the difference between the Female students (as % of total students) in Azerbaijan in 2010 and the Female students (as % of total students) in Slovak Republic in 2012?
Keep it short and to the point. -1.51. What is the difference between the Female students (as % of total students) of Azerbaijan in 2010 and the Female students (as % of total students) of Slovenia in 2012?
Make the answer very short. -1.03. What is the difference between the Female students (as % of total students) of Slovak Republic in 2010 and the Female students (as % of total students) of Slovenia in 2012?
Offer a very short reply. 0.65. What is the difference between the Female students (as % of total students) in High income in 2011 and the Female students (as % of total students) in Azerbaijan in 2012?
Ensure brevity in your answer.  1.68. What is the difference between the Female students (as % of total students) in High income in 2011 and the Female students (as % of total students) in Slovak Republic in 2012?
Provide a short and direct response. -0.25. What is the difference between the Female students (as % of total students) of High income in 2011 and the Female students (as % of total students) of Slovenia in 2012?
Your response must be concise. 0.23. What is the difference between the Female students (as % of total students) in Azerbaijan in 2011 and the Female students (as % of total students) in Slovak Republic in 2012?
Ensure brevity in your answer.  -1.89. What is the difference between the Female students (as % of total students) of Azerbaijan in 2011 and the Female students (as % of total students) of Slovenia in 2012?
Offer a very short reply. -1.41. What is the difference between the Female students (as % of total students) of Slovak Republic in 2011 and the Female students (as % of total students) of Slovenia in 2012?
Offer a terse response. 0.52. What is the average Female students (as % of total students) of High income per year?
Make the answer very short. 48.78. What is the average Female students (as % of total students) of Azerbaijan per year?
Your answer should be compact. 48.08. What is the average Female students (as % of total students) of Slovak Republic per year?
Offer a very short reply. 49.12. What is the average Female students (as % of total students) in Slovenia per year?
Your response must be concise. 48.59. In the year 1997, what is the difference between the Female students (as % of total students) in High income and Female students (as % of total students) in Azerbaijan?
Provide a succinct answer. -2.07. In the year 1997, what is the difference between the Female students (as % of total students) of High income and Female students (as % of total students) of Slovak Republic?
Offer a terse response. -0.44. In the year 1997, what is the difference between the Female students (as % of total students) in High income and Female students (as % of total students) in Slovenia?
Provide a succinct answer. -0.25. In the year 1997, what is the difference between the Female students (as % of total students) of Azerbaijan and Female students (as % of total students) of Slovak Republic?
Your response must be concise. 1.63. In the year 1997, what is the difference between the Female students (as % of total students) of Azerbaijan and Female students (as % of total students) of Slovenia?
Offer a terse response. 1.82. In the year 1997, what is the difference between the Female students (as % of total students) of Slovak Republic and Female students (as % of total students) of Slovenia?
Ensure brevity in your answer.  0.19. In the year 2006, what is the difference between the Female students (as % of total students) of High income and Female students (as % of total students) of Slovak Republic?
Make the answer very short. -0.35. In the year 2006, what is the difference between the Female students (as % of total students) in High income and Female students (as % of total students) in Slovenia?
Provide a succinct answer. 0.08. In the year 2006, what is the difference between the Female students (as % of total students) in Azerbaijan and Female students (as % of total students) in Slovak Republic?
Your answer should be compact. -1.35. In the year 2006, what is the difference between the Female students (as % of total students) of Azerbaijan and Female students (as % of total students) of Slovenia?
Your response must be concise. -0.92. In the year 2006, what is the difference between the Female students (as % of total students) in Slovak Republic and Female students (as % of total students) in Slovenia?
Your answer should be compact. 0.43. In the year 2007, what is the difference between the Female students (as % of total students) of High income and Female students (as % of total students) of Azerbaijan?
Your answer should be compact. 1.07. In the year 2007, what is the difference between the Female students (as % of total students) of High income and Female students (as % of total students) of Slovak Republic?
Ensure brevity in your answer.  -0.27. In the year 2007, what is the difference between the Female students (as % of total students) in High income and Female students (as % of total students) in Slovenia?
Your answer should be compact. 0.29. In the year 2007, what is the difference between the Female students (as % of total students) in Azerbaijan and Female students (as % of total students) in Slovak Republic?
Keep it short and to the point. -1.34. In the year 2007, what is the difference between the Female students (as % of total students) of Azerbaijan and Female students (as % of total students) of Slovenia?
Provide a succinct answer. -0.78. In the year 2007, what is the difference between the Female students (as % of total students) in Slovak Republic and Female students (as % of total students) in Slovenia?
Offer a very short reply. 0.56. In the year 2008, what is the difference between the Female students (as % of total students) in High income and Female students (as % of total students) in Azerbaijan?
Keep it short and to the point. 0.89. In the year 2008, what is the difference between the Female students (as % of total students) in High income and Female students (as % of total students) in Slovak Republic?
Offer a terse response. -0.38. In the year 2008, what is the difference between the Female students (as % of total students) in High income and Female students (as % of total students) in Slovenia?
Your answer should be compact. 0.23. In the year 2008, what is the difference between the Female students (as % of total students) in Azerbaijan and Female students (as % of total students) in Slovak Republic?
Your answer should be compact. -1.27. In the year 2008, what is the difference between the Female students (as % of total students) of Azerbaijan and Female students (as % of total students) of Slovenia?
Ensure brevity in your answer.  -0.66. In the year 2008, what is the difference between the Female students (as % of total students) in Slovak Republic and Female students (as % of total students) in Slovenia?
Offer a very short reply. 0.61. In the year 2009, what is the difference between the Female students (as % of total students) in High income and Female students (as % of total students) in Azerbaijan?
Make the answer very short. 0.07. In the year 2009, what is the difference between the Female students (as % of total students) of High income and Female students (as % of total students) of Slovak Republic?
Ensure brevity in your answer.  -0.37. In the year 2009, what is the difference between the Female students (as % of total students) in High income and Female students (as % of total students) in Slovenia?
Offer a very short reply. 0.22. In the year 2009, what is the difference between the Female students (as % of total students) of Azerbaijan and Female students (as % of total students) of Slovak Republic?
Your response must be concise. -0.43. In the year 2009, what is the difference between the Female students (as % of total students) in Azerbaijan and Female students (as % of total students) in Slovenia?
Your response must be concise. 0.15. In the year 2009, what is the difference between the Female students (as % of total students) in Slovak Republic and Female students (as % of total students) in Slovenia?
Give a very brief answer. 0.58. In the year 2010, what is the difference between the Female students (as % of total students) of High income and Female students (as % of total students) of Azerbaijan?
Your answer should be compact. 1.33. In the year 2010, what is the difference between the Female students (as % of total students) of High income and Female students (as % of total students) of Slovak Republic?
Offer a terse response. -0.35. In the year 2010, what is the difference between the Female students (as % of total students) of High income and Female students (as % of total students) of Slovenia?
Provide a succinct answer. 0.35. In the year 2010, what is the difference between the Female students (as % of total students) of Azerbaijan and Female students (as % of total students) of Slovak Republic?
Provide a succinct answer. -1.68. In the year 2010, what is the difference between the Female students (as % of total students) in Azerbaijan and Female students (as % of total students) in Slovenia?
Your answer should be very brief. -0.98. In the year 2010, what is the difference between the Female students (as % of total students) of Slovak Republic and Female students (as % of total students) of Slovenia?
Offer a terse response. 0.7. In the year 2011, what is the difference between the Female students (as % of total students) of High income and Female students (as % of total students) of Azerbaijan?
Give a very brief answer. 1.64. In the year 2011, what is the difference between the Female students (as % of total students) in High income and Female students (as % of total students) in Slovak Republic?
Your answer should be compact. -0.3. In the year 2011, what is the difference between the Female students (as % of total students) of High income and Female students (as % of total students) of Slovenia?
Your answer should be very brief. 0.33. In the year 2011, what is the difference between the Female students (as % of total students) of Azerbaijan and Female students (as % of total students) of Slovak Republic?
Your response must be concise. -1.93. In the year 2011, what is the difference between the Female students (as % of total students) of Azerbaijan and Female students (as % of total students) of Slovenia?
Give a very brief answer. -1.31. In the year 2011, what is the difference between the Female students (as % of total students) of Slovak Republic and Female students (as % of total students) of Slovenia?
Keep it short and to the point. 0.63. In the year 2012, what is the difference between the Female students (as % of total students) in High income and Female students (as % of total students) in Azerbaijan?
Your answer should be very brief. 1.67. In the year 2012, what is the difference between the Female students (as % of total students) of High income and Female students (as % of total students) of Slovak Republic?
Make the answer very short. -0.26. In the year 2012, what is the difference between the Female students (as % of total students) in High income and Female students (as % of total students) in Slovenia?
Provide a succinct answer. 0.22. In the year 2012, what is the difference between the Female students (as % of total students) in Azerbaijan and Female students (as % of total students) in Slovak Republic?
Offer a terse response. -1.93. In the year 2012, what is the difference between the Female students (as % of total students) of Azerbaijan and Female students (as % of total students) of Slovenia?
Provide a succinct answer. -1.45. In the year 2012, what is the difference between the Female students (as % of total students) of Slovak Republic and Female students (as % of total students) of Slovenia?
Provide a short and direct response. 0.48. What is the ratio of the Female students (as % of total students) in High income in 1997 to that in 2006?
Provide a succinct answer. 1.01. What is the ratio of the Female students (as % of total students) of Azerbaijan in 1997 to that in 2006?
Give a very brief answer. 1.07. What is the ratio of the Female students (as % of total students) of Slovak Republic in 1997 to that in 2006?
Your answer should be compact. 1.01. What is the ratio of the Female students (as % of total students) in Slovenia in 1997 to that in 2006?
Ensure brevity in your answer.  1.02. What is the ratio of the Female students (as % of total students) of High income in 1997 to that in 2007?
Provide a short and direct response. 1.01. What is the ratio of the Female students (as % of total students) of Azerbaijan in 1997 to that in 2007?
Your answer should be very brief. 1.07. What is the ratio of the Female students (as % of total students) of Slovak Republic in 1997 to that in 2007?
Keep it short and to the point. 1.01. What is the ratio of the Female students (as % of total students) in Slovenia in 1997 to that in 2007?
Ensure brevity in your answer.  1.02. What is the ratio of the Female students (as % of total students) of Azerbaijan in 1997 to that in 2008?
Your response must be concise. 1.07. What is the ratio of the Female students (as % of total students) of Slovak Republic in 1997 to that in 2008?
Offer a very short reply. 1.01. What is the ratio of the Female students (as % of total students) of Slovenia in 1997 to that in 2008?
Provide a short and direct response. 1.02. What is the ratio of the Female students (as % of total students) in High income in 1997 to that in 2009?
Provide a short and direct response. 1.01. What is the ratio of the Female students (as % of total students) of Azerbaijan in 1997 to that in 2009?
Your answer should be compact. 1.05. What is the ratio of the Female students (as % of total students) in Slovak Republic in 1997 to that in 2009?
Give a very brief answer. 1.01. What is the ratio of the Female students (as % of total students) of Slovenia in 1997 to that in 2009?
Offer a terse response. 1.02. What is the ratio of the Female students (as % of total students) of High income in 1997 to that in 2010?
Ensure brevity in your answer.  1.01. What is the ratio of the Female students (as % of total students) in Azerbaijan in 1997 to that in 2010?
Make the answer very short. 1.08. What is the ratio of the Female students (as % of total students) of Slovak Republic in 1997 to that in 2010?
Your answer should be compact. 1.01. What is the ratio of the Female students (as % of total students) of Slovenia in 1997 to that in 2010?
Offer a very short reply. 1.02. What is the ratio of the Female students (as % of total students) in High income in 1997 to that in 2011?
Your answer should be very brief. 1.01. What is the ratio of the Female students (as % of total students) of Azerbaijan in 1997 to that in 2011?
Your response must be concise. 1.09. What is the ratio of the Female students (as % of total students) in Slovak Republic in 1997 to that in 2011?
Offer a terse response. 1.01. What is the ratio of the Female students (as % of total students) in Slovenia in 1997 to that in 2011?
Ensure brevity in your answer.  1.02. What is the ratio of the Female students (as % of total students) in High income in 1997 to that in 2012?
Offer a very short reply. 1.01. What is the ratio of the Female students (as % of total students) of Azerbaijan in 1997 to that in 2012?
Your answer should be very brief. 1.09. What is the ratio of the Female students (as % of total students) of Slovak Republic in 1997 to that in 2012?
Your answer should be very brief. 1.02. What is the ratio of the Female students (as % of total students) of Slovenia in 1997 to that in 2012?
Keep it short and to the point. 1.02. What is the ratio of the Female students (as % of total students) of High income in 2006 to that in 2007?
Give a very brief answer. 1. What is the ratio of the Female students (as % of total students) of Azerbaijan in 2006 to that in 2007?
Keep it short and to the point. 1. What is the ratio of the Female students (as % of total students) in Slovak Republic in 2006 to that in 2007?
Ensure brevity in your answer.  1. What is the ratio of the Female students (as % of total students) in Slovenia in 2006 to that in 2007?
Keep it short and to the point. 1. What is the ratio of the Female students (as % of total students) in Azerbaijan in 2006 to that in 2008?
Your answer should be compact. 1. What is the ratio of the Female students (as % of total students) in Slovak Republic in 2006 to that in 2008?
Keep it short and to the point. 1. What is the ratio of the Female students (as % of total students) in High income in 2006 to that in 2009?
Provide a succinct answer. 1. What is the ratio of the Female students (as % of total students) in Azerbaijan in 2006 to that in 2009?
Ensure brevity in your answer.  0.98. What is the ratio of the Female students (as % of total students) in Slovak Republic in 2006 to that in 2009?
Provide a short and direct response. 1. What is the ratio of the Female students (as % of total students) of Azerbaijan in 2006 to that in 2010?
Offer a terse response. 1.01. What is the ratio of the Female students (as % of total students) of Slovak Republic in 2006 to that in 2010?
Ensure brevity in your answer.  1. What is the ratio of the Female students (as % of total students) of Slovenia in 2006 to that in 2010?
Offer a very short reply. 1.01. What is the ratio of the Female students (as % of total students) in Azerbaijan in 2006 to that in 2011?
Your answer should be very brief. 1.02. What is the ratio of the Female students (as % of total students) in Slovak Republic in 2006 to that in 2011?
Give a very brief answer. 1. What is the ratio of the Female students (as % of total students) in Slovenia in 2006 to that in 2011?
Provide a short and direct response. 1.01. What is the ratio of the Female students (as % of total students) of High income in 2006 to that in 2012?
Keep it short and to the point. 1. What is the ratio of the Female students (as % of total students) of Azerbaijan in 2006 to that in 2012?
Your answer should be compact. 1.02. What is the ratio of the Female students (as % of total students) of Slovak Republic in 2006 to that in 2012?
Give a very brief answer. 1. What is the ratio of the Female students (as % of total students) in Slovenia in 2006 to that in 2012?
Provide a succinct answer. 1.01. What is the ratio of the Female students (as % of total students) of High income in 2007 to that in 2008?
Your response must be concise. 1. What is the ratio of the Female students (as % of total students) in Azerbaijan in 2007 to that in 2008?
Provide a succinct answer. 1. What is the ratio of the Female students (as % of total students) in Slovak Republic in 2007 to that in 2008?
Your answer should be very brief. 1. What is the ratio of the Female students (as % of total students) of High income in 2007 to that in 2009?
Ensure brevity in your answer.  1. What is the ratio of the Female students (as % of total students) in Azerbaijan in 2007 to that in 2009?
Make the answer very short. 0.98. What is the ratio of the Female students (as % of total students) of Azerbaijan in 2007 to that in 2010?
Provide a succinct answer. 1.01. What is the ratio of the Female students (as % of total students) of Slovenia in 2007 to that in 2010?
Provide a short and direct response. 1. What is the ratio of the Female students (as % of total students) in Azerbaijan in 2007 to that in 2012?
Keep it short and to the point. 1.02. What is the ratio of the Female students (as % of total students) of Slovenia in 2007 to that in 2012?
Your response must be concise. 1. What is the ratio of the Female students (as % of total students) in High income in 2008 to that in 2009?
Your answer should be very brief. 1. What is the ratio of the Female students (as % of total students) in Azerbaijan in 2008 to that in 2009?
Provide a succinct answer. 0.98. What is the ratio of the Female students (as % of total students) in Slovak Republic in 2008 to that in 2009?
Keep it short and to the point. 1. What is the ratio of the Female students (as % of total students) of High income in 2008 to that in 2010?
Ensure brevity in your answer.  1. What is the ratio of the Female students (as % of total students) of Azerbaijan in 2008 to that in 2010?
Make the answer very short. 1.01. What is the ratio of the Female students (as % of total students) of Slovak Republic in 2008 to that in 2010?
Offer a terse response. 1. What is the ratio of the Female students (as % of total students) in High income in 2008 to that in 2011?
Your answer should be very brief. 1. What is the ratio of the Female students (as % of total students) of Slovak Republic in 2008 to that in 2011?
Your answer should be compact. 1. What is the ratio of the Female students (as % of total students) in High income in 2008 to that in 2012?
Your answer should be compact. 1. What is the ratio of the Female students (as % of total students) in Azerbaijan in 2008 to that in 2012?
Your answer should be compact. 1.02. What is the ratio of the Female students (as % of total students) of High income in 2009 to that in 2010?
Keep it short and to the point. 1. What is the ratio of the Female students (as % of total students) in Azerbaijan in 2009 to that in 2010?
Keep it short and to the point. 1.03. What is the ratio of the Female students (as % of total students) of Slovak Republic in 2009 to that in 2010?
Provide a short and direct response. 1. What is the ratio of the Female students (as % of total students) in Slovenia in 2009 to that in 2010?
Make the answer very short. 1. What is the ratio of the Female students (as % of total students) in High income in 2009 to that in 2011?
Ensure brevity in your answer.  1. What is the ratio of the Female students (as % of total students) in Azerbaijan in 2009 to that in 2011?
Offer a terse response. 1.04. What is the ratio of the Female students (as % of total students) of Slovak Republic in 2009 to that in 2011?
Ensure brevity in your answer.  1. What is the ratio of the Female students (as % of total students) of Slovenia in 2009 to that in 2011?
Make the answer very short. 1.01. What is the ratio of the Female students (as % of total students) of High income in 2009 to that in 2012?
Give a very brief answer. 1. What is the ratio of the Female students (as % of total students) in Azerbaijan in 2009 to that in 2012?
Your answer should be compact. 1.04. What is the ratio of the Female students (as % of total students) in Slovak Republic in 2009 to that in 2012?
Offer a very short reply. 1. What is the ratio of the Female students (as % of total students) of Slovenia in 2009 to that in 2012?
Offer a very short reply. 1. What is the ratio of the Female students (as % of total students) in Slovak Republic in 2010 to that in 2011?
Ensure brevity in your answer.  1. What is the ratio of the Female students (as % of total students) in Azerbaijan in 2010 to that in 2012?
Provide a succinct answer. 1.01. What is the ratio of the Female students (as % of total students) of Slovak Republic in 2010 to that in 2012?
Your response must be concise. 1. What is the ratio of the Female students (as % of total students) of High income in 2011 to that in 2012?
Your response must be concise. 1. What is the ratio of the Female students (as % of total students) in Azerbaijan in 2011 to that in 2012?
Provide a succinct answer. 1. What is the ratio of the Female students (as % of total students) of Slovak Republic in 2011 to that in 2012?
Your answer should be very brief. 1. What is the ratio of the Female students (as % of total students) in Slovenia in 2011 to that in 2012?
Ensure brevity in your answer.  1. What is the difference between the highest and the second highest Female students (as % of total students) of High income?
Your answer should be very brief. 0.4. What is the difference between the highest and the second highest Female students (as % of total students) in Azerbaijan?
Provide a succinct answer. 2.59. What is the difference between the highest and the second highest Female students (as % of total students) in Slovak Republic?
Make the answer very short. 0.53. What is the difference between the highest and the second highest Female students (as % of total students) in Slovenia?
Your answer should be compact. 0.76. What is the difference between the highest and the lowest Female students (as % of total students) of High income?
Your response must be concise. 0.59. What is the difference between the highest and the lowest Female students (as % of total students) in Azerbaijan?
Offer a terse response. 4.33. What is the difference between the highest and the lowest Female students (as % of total students) of Slovak Republic?
Your response must be concise. 0.77. What is the difference between the highest and the lowest Female students (as % of total students) of Slovenia?
Your response must be concise. 1.16. 